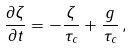<formula> <loc_0><loc_0><loc_500><loc_500>\frac { \partial \zeta } { \partial t } = - \frac { \zeta } { \tau _ { c } } + \frac { g } { \tau _ { c } } \, ,</formula> 